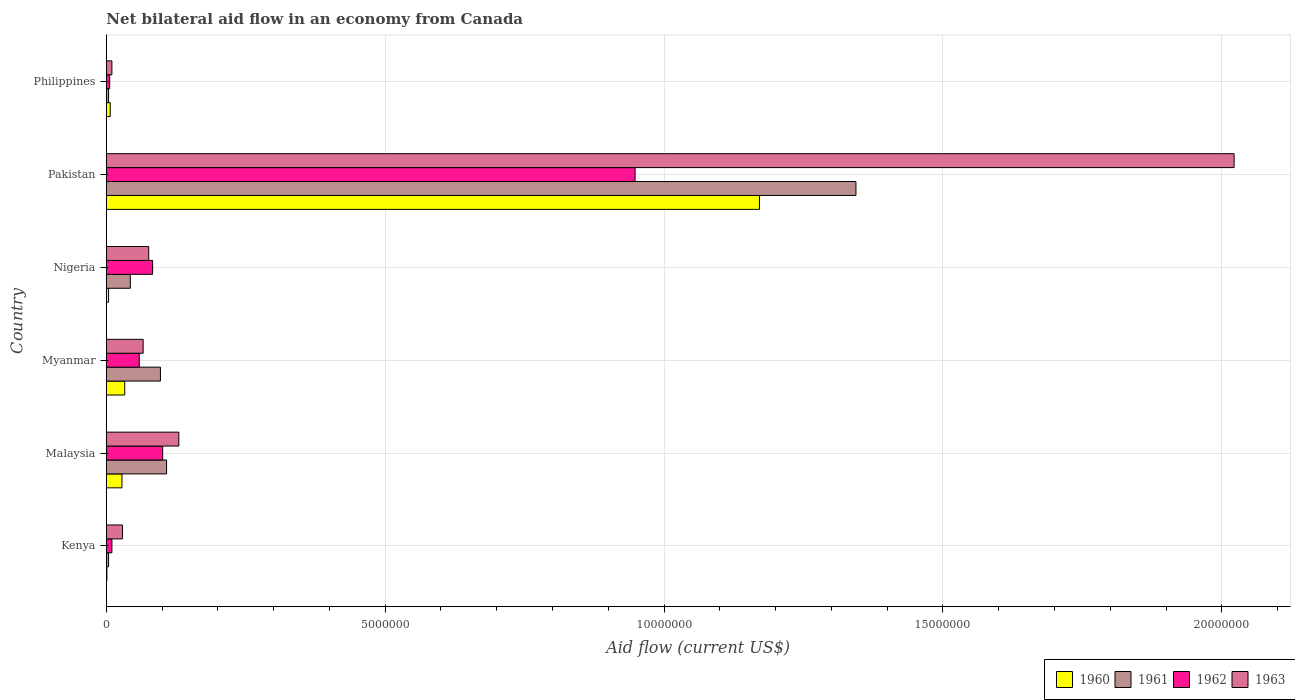How many groups of bars are there?
Keep it short and to the point. 6. How many bars are there on the 4th tick from the top?
Your response must be concise. 4. What is the label of the 4th group of bars from the top?
Your answer should be very brief. Myanmar. Across all countries, what is the maximum net bilateral aid flow in 1960?
Your answer should be compact. 1.17e+07. Across all countries, what is the minimum net bilateral aid flow in 1961?
Provide a succinct answer. 4.00e+04. In which country was the net bilateral aid flow in 1960 maximum?
Give a very brief answer. Pakistan. In which country was the net bilateral aid flow in 1963 minimum?
Your answer should be very brief. Philippines. What is the total net bilateral aid flow in 1961 in the graph?
Keep it short and to the point. 1.60e+07. What is the difference between the net bilateral aid flow in 1963 in Nigeria and the net bilateral aid flow in 1961 in Malaysia?
Offer a terse response. -3.20e+05. What is the average net bilateral aid flow in 1963 per country?
Offer a very short reply. 3.89e+06. What is the difference between the net bilateral aid flow in 1961 and net bilateral aid flow in 1960 in Pakistan?
Keep it short and to the point. 1.73e+06. In how many countries, is the net bilateral aid flow in 1960 greater than 1000000 US$?
Offer a terse response. 1. Is the net bilateral aid flow in 1963 in Malaysia less than that in Pakistan?
Your answer should be compact. Yes. Is the difference between the net bilateral aid flow in 1961 in Kenya and Pakistan greater than the difference between the net bilateral aid flow in 1960 in Kenya and Pakistan?
Ensure brevity in your answer.  No. What is the difference between the highest and the second highest net bilateral aid flow in 1963?
Ensure brevity in your answer.  1.89e+07. What is the difference between the highest and the lowest net bilateral aid flow in 1962?
Offer a terse response. 9.42e+06. Is the sum of the net bilateral aid flow in 1962 in Kenya and Nigeria greater than the maximum net bilateral aid flow in 1961 across all countries?
Your response must be concise. No. What does the 2nd bar from the top in Philippines represents?
Offer a terse response. 1962. Are all the bars in the graph horizontal?
Make the answer very short. Yes. Does the graph contain any zero values?
Your response must be concise. No. How many legend labels are there?
Give a very brief answer. 4. How are the legend labels stacked?
Ensure brevity in your answer.  Horizontal. What is the title of the graph?
Offer a very short reply. Net bilateral aid flow in an economy from Canada. What is the Aid flow (current US$) of 1960 in Kenya?
Provide a succinct answer. 10000. What is the Aid flow (current US$) in 1963 in Kenya?
Offer a terse response. 2.90e+05. What is the Aid flow (current US$) of 1961 in Malaysia?
Your response must be concise. 1.08e+06. What is the Aid flow (current US$) of 1962 in Malaysia?
Provide a short and direct response. 1.01e+06. What is the Aid flow (current US$) in 1963 in Malaysia?
Provide a short and direct response. 1.30e+06. What is the Aid flow (current US$) in 1960 in Myanmar?
Keep it short and to the point. 3.30e+05. What is the Aid flow (current US$) of 1961 in Myanmar?
Offer a terse response. 9.70e+05. What is the Aid flow (current US$) in 1962 in Myanmar?
Your response must be concise. 5.90e+05. What is the Aid flow (current US$) of 1963 in Myanmar?
Give a very brief answer. 6.60e+05. What is the Aid flow (current US$) of 1961 in Nigeria?
Your response must be concise. 4.30e+05. What is the Aid flow (current US$) of 1962 in Nigeria?
Your answer should be very brief. 8.30e+05. What is the Aid flow (current US$) of 1963 in Nigeria?
Provide a short and direct response. 7.60e+05. What is the Aid flow (current US$) in 1960 in Pakistan?
Your answer should be very brief. 1.17e+07. What is the Aid flow (current US$) of 1961 in Pakistan?
Offer a terse response. 1.34e+07. What is the Aid flow (current US$) in 1962 in Pakistan?
Ensure brevity in your answer.  9.48e+06. What is the Aid flow (current US$) of 1963 in Pakistan?
Give a very brief answer. 2.02e+07. What is the Aid flow (current US$) in 1960 in Philippines?
Your answer should be compact. 7.00e+04. Across all countries, what is the maximum Aid flow (current US$) in 1960?
Provide a succinct answer. 1.17e+07. Across all countries, what is the maximum Aid flow (current US$) of 1961?
Make the answer very short. 1.34e+07. Across all countries, what is the maximum Aid flow (current US$) in 1962?
Ensure brevity in your answer.  9.48e+06. Across all countries, what is the maximum Aid flow (current US$) in 1963?
Your answer should be compact. 2.02e+07. Across all countries, what is the minimum Aid flow (current US$) of 1962?
Your answer should be compact. 6.00e+04. Across all countries, what is the minimum Aid flow (current US$) of 1963?
Make the answer very short. 1.00e+05. What is the total Aid flow (current US$) in 1960 in the graph?
Give a very brief answer. 1.24e+07. What is the total Aid flow (current US$) of 1961 in the graph?
Provide a short and direct response. 1.60e+07. What is the total Aid flow (current US$) of 1962 in the graph?
Make the answer very short. 1.21e+07. What is the total Aid flow (current US$) of 1963 in the graph?
Keep it short and to the point. 2.33e+07. What is the difference between the Aid flow (current US$) of 1961 in Kenya and that in Malaysia?
Keep it short and to the point. -1.04e+06. What is the difference between the Aid flow (current US$) of 1962 in Kenya and that in Malaysia?
Your answer should be compact. -9.10e+05. What is the difference between the Aid flow (current US$) in 1963 in Kenya and that in Malaysia?
Give a very brief answer. -1.01e+06. What is the difference between the Aid flow (current US$) of 1960 in Kenya and that in Myanmar?
Give a very brief answer. -3.20e+05. What is the difference between the Aid flow (current US$) of 1961 in Kenya and that in Myanmar?
Your answer should be very brief. -9.30e+05. What is the difference between the Aid flow (current US$) in 1962 in Kenya and that in Myanmar?
Offer a terse response. -4.90e+05. What is the difference between the Aid flow (current US$) in 1963 in Kenya and that in Myanmar?
Offer a very short reply. -3.70e+05. What is the difference between the Aid flow (current US$) of 1960 in Kenya and that in Nigeria?
Your answer should be compact. -3.00e+04. What is the difference between the Aid flow (current US$) in 1961 in Kenya and that in Nigeria?
Provide a succinct answer. -3.90e+05. What is the difference between the Aid flow (current US$) of 1962 in Kenya and that in Nigeria?
Provide a succinct answer. -7.30e+05. What is the difference between the Aid flow (current US$) of 1963 in Kenya and that in Nigeria?
Offer a very short reply. -4.70e+05. What is the difference between the Aid flow (current US$) of 1960 in Kenya and that in Pakistan?
Your answer should be very brief. -1.17e+07. What is the difference between the Aid flow (current US$) of 1961 in Kenya and that in Pakistan?
Keep it short and to the point. -1.34e+07. What is the difference between the Aid flow (current US$) in 1962 in Kenya and that in Pakistan?
Your answer should be compact. -9.38e+06. What is the difference between the Aid flow (current US$) of 1963 in Kenya and that in Pakistan?
Keep it short and to the point. -1.99e+07. What is the difference between the Aid flow (current US$) of 1961 in Kenya and that in Philippines?
Offer a very short reply. 0. What is the difference between the Aid flow (current US$) in 1960 in Malaysia and that in Myanmar?
Ensure brevity in your answer.  -5.00e+04. What is the difference between the Aid flow (current US$) in 1963 in Malaysia and that in Myanmar?
Provide a short and direct response. 6.40e+05. What is the difference between the Aid flow (current US$) in 1960 in Malaysia and that in Nigeria?
Keep it short and to the point. 2.40e+05. What is the difference between the Aid flow (current US$) of 1961 in Malaysia and that in Nigeria?
Make the answer very short. 6.50e+05. What is the difference between the Aid flow (current US$) in 1963 in Malaysia and that in Nigeria?
Ensure brevity in your answer.  5.40e+05. What is the difference between the Aid flow (current US$) of 1960 in Malaysia and that in Pakistan?
Offer a very short reply. -1.14e+07. What is the difference between the Aid flow (current US$) of 1961 in Malaysia and that in Pakistan?
Keep it short and to the point. -1.24e+07. What is the difference between the Aid flow (current US$) in 1962 in Malaysia and that in Pakistan?
Provide a short and direct response. -8.47e+06. What is the difference between the Aid flow (current US$) in 1963 in Malaysia and that in Pakistan?
Your answer should be very brief. -1.89e+07. What is the difference between the Aid flow (current US$) in 1961 in Malaysia and that in Philippines?
Provide a succinct answer. 1.04e+06. What is the difference between the Aid flow (current US$) in 1962 in Malaysia and that in Philippines?
Keep it short and to the point. 9.50e+05. What is the difference between the Aid flow (current US$) in 1963 in Malaysia and that in Philippines?
Ensure brevity in your answer.  1.20e+06. What is the difference between the Aid flow (current US$) in 1961 in Myanmar and that in Nigeria?
Your answer should be compact. 5.40e+05. What is the difference between the Aid flow (current US$) in 1962 in Myanmar and that in Nigeria?
Make the answer very short. -2.40e+05. What is the difference between the Aid flow (current US$) in 1960 in Myanmar and that in Pakistan?
Keep it short and to the point. -1.14e+07. What is the difference between the Aid flow (current US$) in 1961 in Myanmar and that in Pakistan?
Ensure brevity in your answer.  -1.25e+07. What is the difference between the Aid flow (current US$) of 1962 in Myanmar and that in Pakistan?
Keep it short and to the point. -8.89e+06. What is the difference between the Aid flow (current US$) in 1963 in Myanmar and that in Pakistan?
Your answer should be compact. -1.96e+07. What is the difference between the Aid flow (current US$) in 1960 in Myanmar and that in Philippines?
Your answer should be very brief. 2.60e+05. What is the difference between the Aid flow (current US$) in 1961 in Myanmar and that in Philippines?
Your response must be concise. 9.30e+05. What is the difference between the Aid flow (current US$) of 1962 in Myanmar and that in Philippines?
Keep it short and to the point. 5.30e+05. What is the difference between the Aid flow (current US$) in 1963 in Myanmar and that in Philippines?
Provide a succinct answer. 5.60e+05. What is the difference between the Aid flow (current US$) in 1960 in Nigeria and that in Pakistan?
Offer a terse response. -1.17e+07. What is the difference between the Aid flow (current US$) in 1961 in Nigeria and that in Pakistan?
Provide a short and direct response. -1.30e+07. What is the difference between the Aid flow (current US$) of 1962 in Nigeria and that in Pakistan?
Give a very brief answer. -8.65e+06. What is the difference between the Aid flow (current US$) in 1963 in Nigeria and that in Pakistan?
Keep it short and to the point. -1.95e+07. What is the difference between the Aid flow (current US$) of 1961 in Nigeria and that in Philippines?
Your answer should be very brief. 3.90e+05. What is the difference between the Aid flow (current US$) of 1962 in Nigeria and that in Philippines?
Keep it short and to the point. 7.70e+05. What is the difference between the Aid flow (current US$) of 1960 in Pakistan and that in Philippines?
Provide a short and direct response. 1.16e+07. What is the difference between the Aid flow (current US$) of 1961 in Pakistan and that in Philippines?
Keep it short and to the point. 1.34e+07. What is the difference between the Aid flow (current US$) in 1962 in Pakistan and that in Philippines?
Give a very brief answer. 9.42e+06. What is the difference between the Aid flow (current US$) of 1963 in Pakistan and that in Philippines?
Offer a very short reply. 2.01e+07. What is the difference between the Aid flow (current US$) of 1960 in Kenya and the Aid flow (current US$) of 1961 in Malaysia?
Make the answer very short. -1.07e+06. What is the difference between the Aid flow (current US$) in 1960 in Kenya and the Aid flow (current US$) in 1962 in Malaysia?
Provide a succinct answer. -1.00e+06. What is the difference between the Aid flow (current US$) in 1960 in Kenya and the Aid flow (current US$) in 1963 in Malaysia?
Keep it short and to the point. -1.29e+06. What is the difference between the Aid flow (current US$) in 1961 in Kenya and the Aid flow (current US$) in 1962 in Malaysia?
Your answer should be compact. -9.70e+05. What is the difference between the Aid flow (current US$) of 1961 in Kenya and the Aid flow (current US$) of 1963 in Malaysia?
Offer a terse response. -1.26e+06. What is the difference between the Aid flow (current US$) in 1962 in Kenya and the Aid flow (current US$) in 1963 in Malaysia?
Offer a terse response. -1.20e+06. What is the difference between the Aid flow (current US$) in 1960 in Kenya and the Aid flow (current US$) in 1961 in Myanmar?
Give a very brief answer. -9.60e+05. What is the difference between the Aid flow (current US$) of 1960 in Kenya and the Aid flow (current US$) of 1962 in Myanmar?
Provide a succinct answer. -5.80e+05. What is the difference between the Aid flow (current US$) in 1960 in Kenya and the Aid flow (current US$) in 1963 in Myanmar?
Keep it short and to the point. -6.50e+05. What is the difference between the Aid flow (current US$) of 1961 in Kenya and the Aid flow (current US$) of 1962 in Myanmar?
Ensure brevity in your answer.  -5.50e+05. What is the difference between the Aid flow (current US$) in 1961 in Kenya and the Aid flow (current US$) in 1963 in Myanmar?
Provide a succinct answer. -6.20e+05. What is the difference between the Aid flow (current US$) in 1962 in Kenya and the Aid flow (current US$) in 1963 in Myanmar?
Ensure brevity in your answer.  -5.60e+05. What is the difference between the Aid flow (current US$) in 1960 in Kenya and the Aid flow (current US$) in 1961 in Nigeria?
Your answer should be very brief. -4.20e+05. What is the difference between the Aid flow (current US$) of 1960 in Kenya and the Aid flow (current US$) of 1962 in Nigeria?
Offer a terse response. -8.20e+05. What is the difference between the Aid flow (current US$) in 1960 in Kenya and the Aid flow (current US$) in 1963 in Nigeria?
Provide a short and direct response. -7.50e+05. What is the difference between the Aid flow (current US$) in 1961 in Kenya and the Aid flow (current US$) in 1962 in Nigeria?
Offer a terse response. -7.90e+05. What is the difference between the Aid flow (current US$) in 1961 in Kenya and the Aid flow (current US$) in 1963 in Nigeria?
Your response must be concise. -7.20e+05. What is the difference between the Aid flow (current US$) in 1962 in Kenya and the Aid flow (current US$) in 1963 in Nigeria?
Give a very brief answer. -6.60e+05. What is the difference between the Aid flow (current US$) of 1960 in Kenya and the Aid flow (current US$) of 1961 in Pakistan?
Your response must be concise. -1.34e+07. What is the difference between the Aid flow (current US$) in 1960 in Kenya and the Aid flow (current US$) in 1962 in Pakistan?
Your answer should be compact. -9.47e+06. What is the difference between the Aid flow (current US$) of 1960 in Kenya and the Aid flow (current US$) of 1963 in Pakistan?
Offer a terse response. -2.02e+07. What is the difference between the Aid flow (current US$) of 1961 in Kenya and the Aid flow (current US$) of 1962 in Pakistan?
Your response must be concise. -9.44e+06. What is the difference between the Aid flow (current US$) of 1961 in Kenya and the Aid flow (current US$) of 1963 in Pakistan?
Keep it short and to the point. -2.02e+07. What is the difference between the Aid flow (current US$) in 1962 in Kenya and the Aid flow (current US$) in 1963 in Pakistan?
Keep it short and to the point. -2.01e+07. What is the difference between the Aid flow (current US$) of 1960 in Kenya and the Aid flow (current US$) of 1962 in Philippines?
Provide a succinct answer. -5.00e+04. What is the difference between the Aid flow (current US$) in 1960 in Kenya and the Aid flow (current US$) in 1963 in Philippines?
Keep it short and to the point. -9.00e+04. What is the difference between the Aid flow (current US$) of 1961 in Kenya and the Aid flow (current US$) of 1963 in Philippines?
Offer a very short reply. -6.00e+04. What is the difference between the Aid flow (current US$) in 1960 in Malaysia and the Aid flow (current US$) in 1961 in Myanmar?
Your answer should be very brief. -6.90e+05. What is the difference between the Aid flow (current US$) of 1960 in Malaysia and the Aid flow (current US$) of 1962 in Myanmar?
Make the answer very short. -3.10e+05. What is the difference between the Aid flow (current US$) of 1960 in Malaysia and the Aid flow (current US$) of 1963 in Myanmar?
Your response must be concise. -3.80e+05. What is the difference between the Aid flow (current US$) in 1961 in Malaysia and the Aid flow (current US$) in 1962 in Myanmar?
Your answer should be compact. 4.90e+05. What is the difference between the Aid flow (current US$) of 1961 in Malaysia and the Aid flow (current US$) of 1963 in Myanmar?
Give a very brief answer. 4.20e+05. What is the difference between the Aid flow (current US$) of 1960 in Malaysia and the Aid flow (current US$) of 1961 in Nigeria?
Offer a terse response. -1.50e+05. What is the difference between the Aid flow (current US$) in 1960 in Malaysia and the Aid flow (current US$) in 1962 in Nigeria?
Your answer should be very brief. -5.50e+05. What is the difference between the Aid flow (current US$) of 1960 in Malaysia and the Aid flow (current US$) of 1963 in Nigeria?
Ensure brevity in your answer.  -4.80e+05. What is the difference between the Aid flow (current US$) in 1961 in Malaysia and the Aid flow (current US$) in 1962 in Nigeria?
Offer a very short reply. 2.50e+05. What is the difference between the Aid flow (current US$) of 1961 in Malaysia and the Aid flow (current US$) of 1963 in Nigeria?
Your response must be concise. 3.20e+05. What is the difference between the Aid flow (current US$) of 1960 in Malaysia and the Aid flow (current US$) of 1961 in Pakistan?
Make the answer very short. -1.32e+07. What is the difference between the Aid flow (current US$) in 1960 in Malaysia and the Aid flow (current US$) in 1962 in Pakistan?
Provide a succinct answer. -9.20e+06. What is the difference between the Aid flow (current US$) in 1960 in Malaysia and the Aid flow (current US$) in 1963 in Pakistan?
Offer a very short reply. -1.99e+07. What is the difference between the Aid flow (current US$) in 1961 in Malaysia and the Aid flow (current US$) in 1962 in Pakistan?
Give a very brief answer. -8.40e+06. What is the difference between the Aid flow (current US$) in 1961 in Malaysia and the Aid flow (current US$) in 1963 in Pakistan?
Keep it short and to the point. -1.91e+07. What is the difference between the Aid flow (current US$) of 1962 in Malaysia and the Aid flow (current US$) of 1963 in Pakistan?
Provide a succinct answer. -1.92e+07. What is the difference between the Aid flow (current US$) in 1960 in Malaysia and the Aid flow (current US$) in 1962 in Philippines?
Ensure brevity in your answer.  2.20e+05. What is the difference between the Aid flow (current US$) of 1961 in Malaysia and the Aid flow (current US$) of 1962 in Philippines?
Provide a succinct answer. 1.02e+06. What is the difference between the Aid flow (current US$) of 1961 in Malaysia and the Aid flow (current US$) of 1963 in Philippines?
Your answer should be very brief. 9.80e+05. What is the difference between the Aid flow (current US$) in 1962 in Malaysia and the Aid flow (current US$) in 1963 in Philippines?
Make the answer very short. 9.10e+05. What is the difference between the Aid flow (current US$) of 1960 in Myanmar and the Aid flow (current US$) of 1961 in Nigeria?
Your response must be concise. -1.00e+05. What is the difference between the Aid flow (current US$) in 1960 in Myanmar and the Aid flow (current US$) in 1962 in Nigeria?
Your answer should be compact. -5.00e+05. What is the difference between the Aid flow (current US$) in 1960 in Myanmar and the Aid flow (current US$) in 1963 in Nigeria?
Your answer should be very brief. -4.30e+05. What is the difference between the Aid flow (current US$) of 1961 in Myanmar and the Aid flow (current US$) of 1962 in Nigeria?
Ensure brevity in your answer.  1.40e+05. What is the difference between the Aid flow (current US$) in 1960 in Myanmar and the Aid flow (current US$) in 1961 in Pakistan?
Ensure brevity in your answer.  -1.31e+07. What is the difference between the Aid flow (current US$) of 1960 in Myanmar and the Aid flow (current US$) of 1962 in Pakistan?
Your answer should be compact. -9.15e+06. What is the difference between the Aid flow (current US$) in 1960 in Myanmar and the Aid flow (current US$) in 1963 in Pakistan?
Offer a very short reply. -1.99e+07. What is the difference between the Aid flow (current US$) in 1961 in Myanmar and the Aid flow (current US$) in 1962 in Pakistan?
Ensure brevity in your answer.  -8.51e+06. What is the difference between the Aid flow (current US$) of 1961 in Myanmar and the Aid flow (current US$) of 1963 in Pakistan?
Ensure brevity in your answer.  -1.92e+07. What is the difference between the Aid flow (current US$) of 1962 in Myanmar and the Aid flow (current US$) of 1963 in Pakistan?
Your answer should be compact. -1.96e+07. What is the difference between the Aid flow (current US$) of 1960 in Myanmar and the Aid flow (current US$) of 1961 in Philippines?
Offer a terse response. 2.90e+05. What is the difference between the Aid flow (current US$) in 1960 in Myanmar and the Aid flow (current US$) in 1962 in Philippines?
Provide a short and direct response. 2.70e+05. What is the difference between the Aid flow (current US$) in 1960 in Myanmar and the Aid flow (current US$) in 1963 in Philippines?
Your answer should be very brief. 2.30e+05. What is the difference between the Aid flow (current US$) in 1961 in Myanmar and the Aid flow (current US$) in 1962 in Philippines?
Keep it short and to the point. 9.10e+05. What is the difference between the Aid flow (current US$) of 1961 in Myanmar and the Aid flow (current US$) of 1963 in Philippines?
Keep it short and to the point. 8.70e+05. What is the difference between the Aid flow (current US$) in 1962 in Myanmar and the Aid flow (current US$) in 1963 in Philippines?
Offer a terse response. 4.90e+05. What is the difference between the Aid flow (current US$) of 1960 in Nigeria and the Aid flow (current US$) of 1961 in Pakistan?
Make the answer very short. -1.34e+07. What is the difference between the Aid flow (current US$) of 1960 in Nigeria and the Aid flow (current US$) of 1962 in Pakistan?
Offer a terse response. -9.44e+06. What is the difference between the Aid flow (current US$) of 1960 in Nigeria and the Aid flow (current US$) of 1963 in Pakistan?
Provide a succinct answer. -2.02e+07. What is the difference between the Aid flow (current US$) of 1961 in Nigeria and the Aid flow (current US$) of 1962 in Pakistan?
Your answer should be compact. -9.05e+06. What is the difference between the Aid flow (current US$) of 1961 in Nigeria and the Aid flow (current US$) of 1963 in Pakistan?
Give a very brief answer. -1.98e+07. What is the difference between the Aid flow (current US$) in 1962 in Nigeria and the Aid flow (current US$) in 1963 in Pakistan?
Offer a terse response. -1.94e+07. What is the difference between the Aid flow (current US$) in 1960 in Nigeria and the Aid flow (current US$) in 1963 in Philippines?
Keep it short and to the point. -6.00e+04. What is the difference between the Aid flow (current US$) of 1961 in Nigeria and the Aid flow (current US$) of 1962 in Philippines?
Offer a very short reply. 3.70e+05. What is the difference between the Aid flow (current US$) in 1961 in Nigeria and the Aid flow (current US$) in 1963 in Philippines?
Your answer should be compact. 3.30e+05. What is the difference between the Aid flow (current US$) in 1962 in Nigeria and the Aid flow (current US$) in 1963 in Philippines?
Provide a short and direct response. 7.30e+05. What is the difference between the Aid flow (current US$) in 1960 in Pakistan and the Aid flow (current US$) in 1961 in Philippines?
Your response must be concise. 1.17e+07. What is the difference between the Aid flow (current US$) of 1960 in Pakistan and the Aid flow (current US$) of 1962 in Philippines?
Offer a terse response. 1.16e+07. What is the difference between the Aid flow (current US$) of 1960 in Pakistan and the Aid flow (current US$) of 1963 in Philippines?
Provide a succinct answer. 1.16e+07. What is the difference between the Aid flow (current US$) in 1961 in Pakistan and the Aid flow (current US$) in 1962 in Philippines?
Give a very brief answer. 1.34e+07. What is the difference between the Aid flow (current US$) in 1961 in Pakistan and the Aid flow (current US$) in 1963 in Philippines?
Provide a succinct answer. 1.33e+07. What is the difference between the Aid flow (current US$) of 1962 in Pakistan and the Aid flow (current US$) of 1963 in Philippines?
Your answer should be compact. 9.38e+06. What is the average Aid flow (current US$) of 1960 per country?
Give a very brief answer. 2.07e+06. What is the average Aid flow (current US$) of 1961 per country?
Offer a terse response. 2.67e+06. What is the average Aid flow (current US$) of 1962 per country?
Offer a terse response. 2.01e+06. What is the average Aid flow (current US$) in 1963 per country?
Provide a short and direct response. 3.89e+06. What is the difference between the Aid flow (current US$) of 1960 and Aid flow (current US$) of 1961 in Kenya?
Provide a short and direct response. -3.00e+04. What is the difference between the Aid flow (current US$) of 1960 and Aid flow (current US$) of 1962 in Kenya?
Provide a succinct answer. -9.00e+04. What is the difference between the Aid flow (current US$) of 1960 and Aid flow (current US$) of 1963 in Kenya?
Your response must be concise. -2.80e+05. What is the difference between the Aid flow (current US$) in 1961 and Aid flow (current US$) in 1963 in Kenya?
Provide a succinct answer. -2.50e+05. What is the difference between the Aid flow (current US$) in 1962 and Aid flow (current US$) in 1963 in Kenya?
Give a very brief answer. -1.90e+05. What is the difference between the Aid flow (current US$) of 1960 and Aid flow (current US$) of 1961 in Malaysia?
Make the answer very short. -8.00e+05. What is the difference between the Aid flow (current US$) of 1960 and Aid flow (current US$) of 1962 in Malaysia?
Your answer should be very brief. -7.30e+05. What is the difference between the Aid flow (current US$) in 1960 and Aid flow (current US$) in 1963 in Malaysia?
Keep it short and to the point. -1.02e+06. What is the difference between the Aid flow (current US$) in 1961 and Aid flow (current US$) in 1963 in Malaysia?
Your answer should be very brief. -2.20e+05. What is the difference between the Aid flow (current US$) of 1960 and Aid flow (current US$) of 1961 in Myanmar?
Ensure brevity in your answer.  -6.40e+05. What is the difference between the Aid flow (current US$) in 1960 and Aid flow (current US$) in 1962 in Myanmar?
Provide a succinct answer. -2.60e+05. What is the difference between the Aid flow (current US$) in 1960 and Aid flow (current US$) in 1963 in Myanmar?
Your answer should be very brief. -3.30e+05. What is the difference between the Aid flow (current US$) of 1961 and Aid flow (current US$) of 1962 in Myanmar?
Provide a succinct answer. 3.80e+05. What is the difference between the Aid flow (current US$) in 1962 and Aid flow (current US$) in 1963 in Myanmar?
Your answer should be very brief. -7.00e+04. What is the difference between the Aid flow (current US$) of 1960 and Aid flow (current US$) of 1961 in Nigeria?
Ensure brevity in your answer.  -3.90e+05. What is the difference between the Aid flow (current US$) in 1960 and Aid flow (current US$) in 1962 in Nigeria?
Your answer should be compact. -7.90e+05. What is the difference between the Aid flow (current US$) of 1960 and Aid flow (current US$) of 1963 in Nigeria?
Your answer should be very brief. -7.20e+05. What is the difference between the Aid flow (current US$) of 1961 and Aid flow (current US$) of 1962 in Nigeria?
Provide a short and direct response. -4.00e+05. What is the difference between the Aid flow (current US$) in 1961 and Aid flow (current US$) in 1963 in Nigeria?
Your answer should be compact. -3.30e+05. What is the difference between the Aid flow (current US$) in 1962 and Aid flow (current US$) in 1963 in Nigeria?
Keep it short and to the point. 7.00e+04. What is the difference between the Aid flow (current US$) of 1960 and Aid flow (current US$) of 1961 in Pakistan?
Offer a terse response. -1.73e+06. What is the difference between the Aid flow (current US$) in 1960 and Aid flow (current US$) in 1962 in Pakistan?
Your answer should be compact. 2.23e+06. What is the difference between the Aid flow (current US$) of 1960 and Aid flow (current US$) of 1963 in Pakistan?
Your answer should be compact. -8.51e+06. What is the difference between the Aid flow (current US$) in 1961 and Aid flow (current US$) in 1962 in Pakistan?
Make the answer very short. 3.96e+06. What is the difference between the Aid flow (current US$) in 1961 and Aid flow (current US$) in 1963 in Pakistan?
Offer a very short reply. -6.78e+06. What is the difference between the Aid flow (current US$) of 1962 and Aid flow (current US$) of 1963 in Pakistan?
Provide a short and direct response. -1.07e+07. What is the difference between the Aid flow (current US$) in 1960 and Aid flow (current US$) in 1962 in Philippines?
Provide a short and direct response. 10000. What is the difference between the Aid flow (current US$) of 1961 and Aid flow (current US$) of 1963 in Philippines?
Your response must be concise. -6.00e+04. What is the difference between the Aid flow (current US$) in 1962 and Aid flow (current US$) in 1963 in Philippines?
Your answer should be very brief. -4.00e+04. What is the ratio of the Aid flow (current US$) in 1960 in Kenya to that in Malaysia?
Keep it short and to the point. 0.04. What is the ratio of the Aid flow (current US$) of 1961 in Kenya to that in Malaysia?
Offer a very short reply. 0.04. What is the ratio of the Aid flow (current US$) in 1962 in Kenya to that in Malaysia?
Give a very brief answer. 0.1. What is the ratio of the Aid flow (current US$) of 1963 in Kenya to that in Malaysia?
Offer a very short reply. 0.22. What is the ratio of the Aid flow (current US$) in 1960 in Kenya to that in Myanmar?
Keep it short and to the point. 0.03. What is the ratio of the Aid flow (current US$) of 1961 in Kenya to that in Myanmar?
Provide a succinct answer. 0.04. What is the ratio of the Aid flow (current US$) of 1962 in Kenya to that in Myanmar?
Ensure brevity in your answer.  0.17. What is the ratio of the Aid flow (current US$) in 1963 in Kenya to that in Myanmar?
Your answer should be compact. 0.44. What is the ratio of the Aid flow (current US$) of 1960 in Kenya to that in Nigeria?
Make the answer very short. 0.25. What is the ratio of the Aid flow (current US$) in 1961 in Kenya to that in Nigeria?
Your answer should be very brief. 0.09. What is the ratio of the Aid flow (current US$) of 1962 in Kenya to that in Nigeria?
Ensure brevity in your answer.  0.12. What is the ratio of the Aid flow (current US$) in 1963 in Kenya to that in Nigeria?
Give a very brief answer. 0.38. What is the ratio of the Aid flow (current US$) of 1960 in Kenya to that in Pakistan?
Offer a very short reply. 0. What is the ratio of the Aid flow (current US$) of 1961 in Kenya to that in Pakistan?
Give a very brief answer. 0. What is the ratio of the Aid flow (current US$) in 1962 in Kenya to that in Pakistan?
Your answer should be compact. 0.01. What is the ratio of the Aid flow (current US$) in 1963 in Kenya to that in Pakistan?
Provide a succinct answer. 0.01. What is the ratio of the Aid flow (current US$) in 1960 in Kenya to that in Philippines?
Offer a very short reply. 0.14. What is the ratio of the Aid flow (current US$) in 1961 in Kenya to that in Philippines?
Provide a succinct answer. 1. What is the ratio of the Aid flow (current US$) in 1962 in Kenya to that in Philippines?
Make the answer very short. 1.67. What is the ratio of the Aid flow (current US$) of 1960 in Malaysia to that in Myanmar?
Provide a short and direct response. 0.85. What is the ratio of the Aid flow (current US$) of 1961 in Malaysia to that in Myanmar?
Your answer should be very brief. 1.11. What is the ratio of the Aid flow (current US$) in 1962 in Malaysia to that in Myanmar?
Give a very brief answer. 1.71. What is the ratio of the Aid flow (current US$) of 1963 in Malaysia to that in Myanmar?
Ensure brevity in your answer.  1.97. What is the ratio of the Aid flow (current US$) in 1960 in Malaysia to that in Nigeria?
Make the answer very short. 7. What is the ratio of the Aid flow (current US$) of 1961 in Malaysia to that in Nigeria?
Keep it short and to the point. 2.51. What is the ratio of the Aid flow (current US$) in 1962 in Malaysia to that in Nigeria?
Provide a succinct answer. 1.22. What is the ratio of the Aid flow (current US$) in 1963 in Malaysia to that in Nigeria?
Ensure brevity in your answer.  1.71. What is the ratio of the Aid flow (current US$) in 1960 in Malaysia to that in Pakistan?
Make the answer very short. 0.02. What is the ratio of the Aid flow (current US$) in 1961 in Malaysia to that in Pakistan?
Offer a very short reply. 0.08. What is the ratio of the Aid flow (current US$) in 1962 in Malaysia to that in Pakistan?
Make the answer very short. 0.11. What is the ratio of the Aid flow (current US$) in 1963 in Malaysia to that in Pakistan?
Your answer should be compact. 0.06. What is the ratio of the Aid flow (current US$) of 1960 in Malaysia to that in Philippines?
Provide a succinct answer. 4. What is the ratio of the Aid flow (current US$) in 1962 in Malaysia to that in Philippines?
Keep it short and to the point. 16.83. What is the ratio of the Aid flow (current US$) in 1960 in Myanmar to that in Nigeria?
Your response must be concise. 8.25. What is the ratio of the Aid flow (current US$) in 1961 in Myanmar to that in Nigeria?
Provide a succinct answer. 2.26. What is the ratio of the Aid flow (current US$) of 1962 in Myanmar to that in Nigeria?
Provide a succinct answer. 0.71. What is the ratio of the Aid flow (current US$) in 1963 in Myanmar to that in Nigeria?
Provide a short and direct response. 0.87. What is the ratio of the Aid flow (current US$) of 1960 in Myanmar to that in Pakistan?
Give a very brief answer. 0.03. What is the ratio of the Aid flow (current US$) in 1961 in Myanmar to that in Pakistan?
Make the answer very short. 0.07. What is the ratio of the Aid flow (current US$) in 1962 in Myanmar to that in Pakistan?
Your answer should be very brief. 0.06. What is the ratio of the Aid flow (current US$) in 1963 in Myanmar to that in Pakistan?
Keep it short and to the point. 0.03. What is the ratio of the Aid flow (current US$) of 1960 in Myanmar to that in Philippines?
Offer a terse response. 4.71. What is the ratio of the Aid flow (current US$) in 1961 in Myanmar to that in Philippines?
Offer a very short reply. 24.25. What is the ratio of the Aid flow (current US$) in 1962 in Myanmar to that in Philippines?
Offer a terse response. 9.83. What is the ratio of the Aid flow (current US$) in 1960 in Nigeria to that in Pakistan?
Your response must be concise. 0. What is the ratio of the Aid flow (current US$) in 1961 in Nigeria to that in Pakistan?
Your answer should be very brief. 0.03. What is the ratio of the Aid flow (current US$) of 1962 in Nigeria to that in Pakistan?
Ensure brevity in your answer.  0.09. What is the ratio of the Aid flow (current US$) of 1963 in Nigeria to that in Pakistan?
Make the answer very short. 0.04. What is the ratio of the Aid flow (current US$) in 1961 in Nigeria to that in Philippines?
Offer a very short reply. 10.75. What is the ratio of the Aid flow (current US$) of 1962 in Nigeria to that in Philippines?
Offer a very short reply. 13.83. What is the ratio of the Aid flow (current US$) of 1960 in Pakistan to that in Philippines?
Offer a terse response. 167.29. What is the ratio of the Aid flow (current US$) in 1961 in Pakistan to that in Philippines?
Make the answer very short. 336. What is the ratio of the Aid flow (current US$) of 1962 in Pakistan to that in Philippines?
Ensure brevity in your answer.  158. What is the ratio of the Aid flow (current US$) in 1963 in Pakistan to that in Philippines?
Offer a terse response. 202.2. What is the difference between the highest and the second highest Aid flow (current US$) of 1960?
Provide a succinct answer. 1.14e+07. What is the difference between the highest and the second highest Aid flow (current US$) in 1961?
Offer a terse response. 1.24e+07. What is the difference between the highest and the second highest Aid flow (current US$) of 1962?
Keep it short and to the point. 8.47e+06. What is the difference between the highest and the second highest Aid flow (current US$) of 1963?
Provide a short and direct response. 1.89e+07. What is the difference between the highest and the lowest Aid flow (current US$) in 1960?
Your answer should be compact. 1.17e+07. What is the difference between the highest and the lowest Aid flow (current US$) in 1961?
Your response must be concise. 1.34e+07. What is the difference between the highest and the lowest Aid flow (current US$) of 1962?
Provide a short and direct response. 9.42e+06. What is the difference between the highest and the lowest Aid flow (current US$) of 1963?
Offer a terse response. 2.01e+07. 